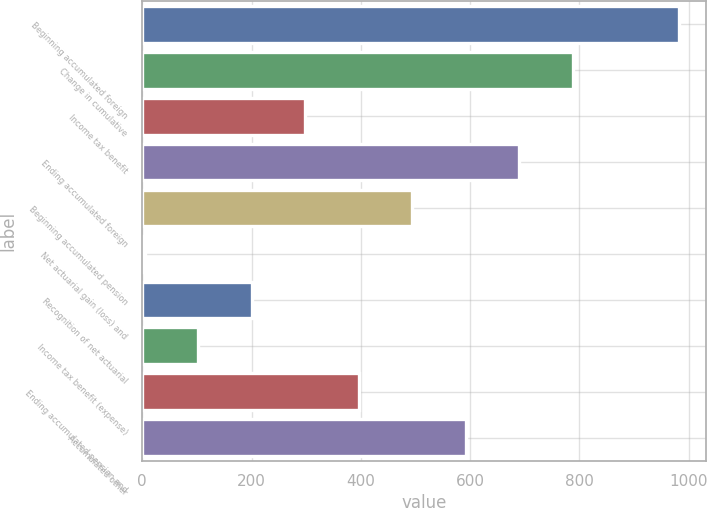Convert chart. <chart><loc_0><loc_0><loc_500><loc_500><bar_chart><fcel>Beginning accumulated foreign<fcel>Change in cumulative<fcel>Income tax benefit<fcel>Ending accumulated foreign<fcel>Beginning accumulated pension<fcel>Net actuarial gain (loss) and<fcel>Recognition of net actuarial<fcel>Income tax benefit (expense)<fcel>Ending accumulated pension and<fcel>Accumulated other<nl><fcel>983<fcel>787.4<fcel>298.4<fcel>689.6<fcel>494<fcel>5<fcel>200.6<fcel>102.8<fcel>396.2<fcel>591.8<nl></chart> 